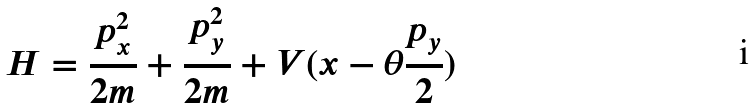<formula> <loc_0><loc_0><loc_500><loc_500>H = \frac { p _ { x } ^ { 2 } } { 2 m } + \frac { p _ { y } ^ { 2 } } { 2 m } + V ( x - \theta \frac { p _ { y } } { 2 } )</formula> 